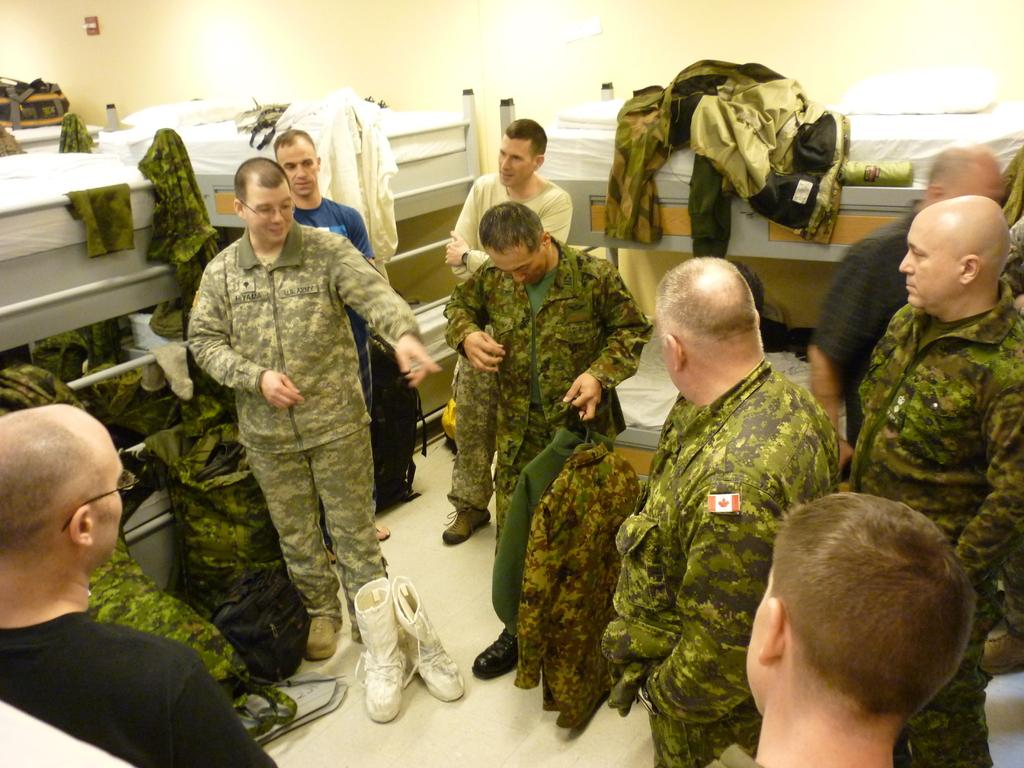How many people are in the image? There is a group of people in the image, but the exact number cannot be determined from the provided facts. What is the position of the people in the image? The people are standing on the floor in the image. What type of footwear is visible in the image? Shoes are visible in the image. What type of clothing can be seen in the image? Clothes are present in the image. What type of furniture is in the image? Bunk beds are in the image. What type of personal items are visible in the image? Bags are visible in the image. What is in the background of the image? There is a wall in the background of the image. What type of line can be seen in the image? There is no line present in the image. What are the people in the image afraid of? The provided facts do not give any information about the emotions or fears of the people in the image. What type of cannon is visible in the image? There is no cannon present in the image. 